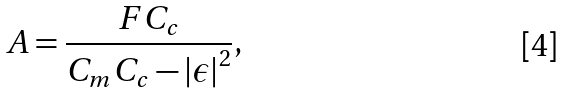Convert formula to latex. <formula><loc_0><loc_0><loc_500><loc_500>A = \frac { F C _ { c } } { C _ { m } C _ { c } - \left | \epsilon \right | ^ { 2 } } ,</formula> 